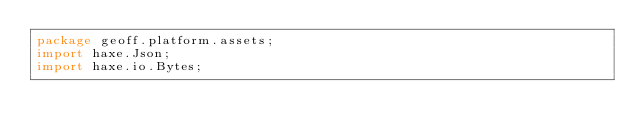<code> <loc_0><loc_0><loc_500><loc_500><_Haxe_>package geoff.platform.assets;
import haxe.Json;
import haxe.io.Bytes;</code> 